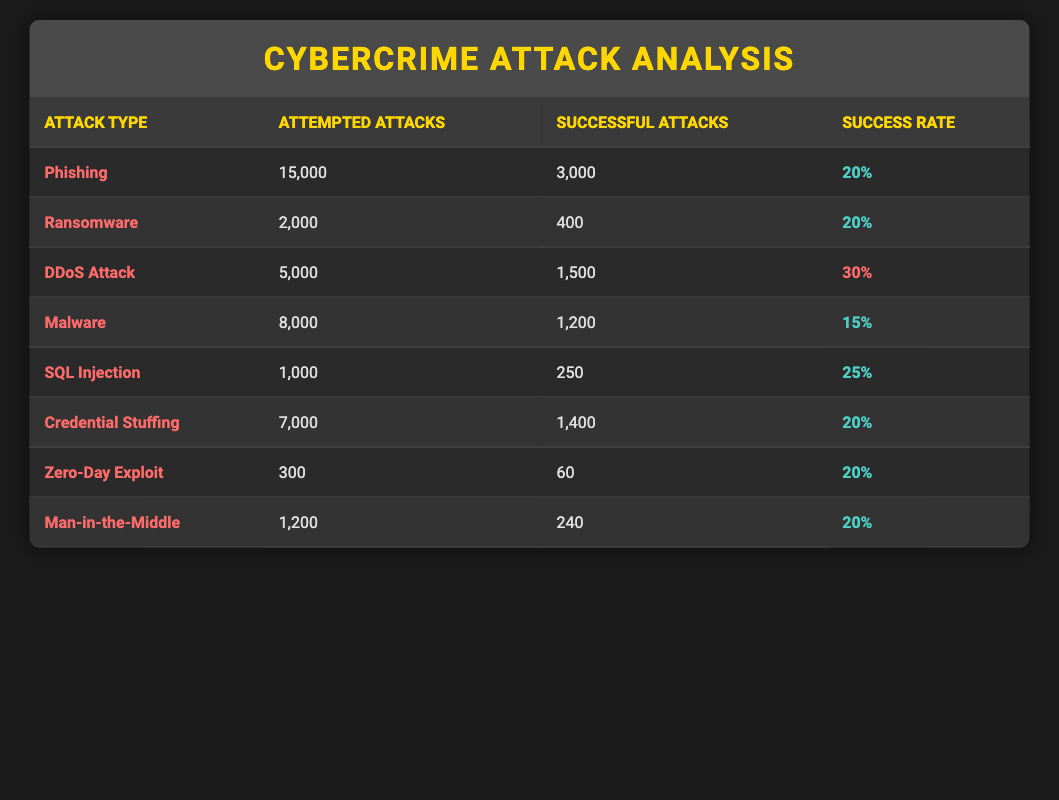What is the total number of attempted attacks across all types? To find the total number of attempted attacks, sum the values in the "Attempted Attacks" column: 15000 (Phishing) + 2000 (Ransomware) + 5000 (DDoS Attack) + 8000 (Malware) + 1000 (SQL Injection) + 7000 (Credential Stuffing) + 300 (Zero-Day Exploit) + 1200 (Man-in-the-Middle) = 36,500
Answer: 36500 Which attack type has the highest success rate among the entries? The highest success rate can be found in the "Success Rate" column. The DDoS Attack has a success rate of 30%, which is higher than any other type listed.
Answer: DDoS Attack How many successful attacks were recorded for SQL Injection? From the "Successful Attacks" column under SQL Injection, the value is 250 successful attacks recorded.
Answer: 250 Did any attack type have a success rate above 20%? Yes, the DDoS Attack has a success rate of 30%, which is above 20%.
Answer: Yes What is the difference in successful attacks between Phishing and Malware? To find the difference, subtract the successful attacks for Malware (1200) from Phishing (3000): 3000 - 1200 = 1800.
Answer: 1800 Which attack type had the least number of attempted attacks? The attack type with the least number of attempted attacks is Zero-Day Exploit, with only 300 attempted attacks.
Answer: Zero-Day Exploit What percentage of successful attacks came from Credential Stuffing compared to the overall successful attacks? First, calculate the total successful attacks: 3000 (Phishing) + 400 (Ransomware) + 1500 (DDoS Attack) + 1200 (Malware) + 250 (SQL Injection) + 1400 (Credential Stuffing) + 60 (Zero-Day Exploit) + 240 (Man-in-the-Middle) = 8300. Then determine Credential Stuffing's percentage: (1400 / 8300) * 100 = 16.87%.
Answer: 16.87% Is it true that there were more than 700 successful attacks for the DDoS Attack type? Yes, the DDoS Attack type recorded 1500 successful attacks, which is more than 700.
Answer: Yes What is the average success rate of the attempted cyber attacks? To find the average success rate, sum the percentages: 20 + 20 + 30 + 15 + 25 + 20 + 20 + 20 = 200. Divide by the number of attack types (8): 200 / 8 = 25%.
Answer: 25% 